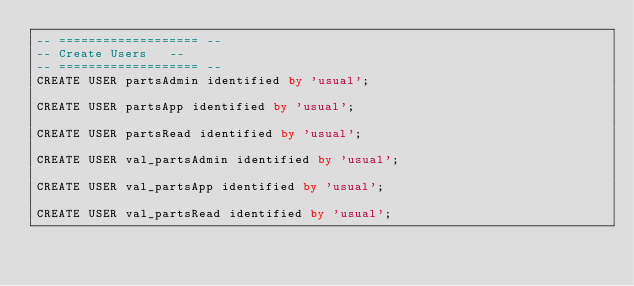Convert code to text. <code><loc_0><loc_0><loc_500><loc_500><_SQL_>-- =================== --
-- Create Users   --
-- =================== --
CREATE USER partsAdmin identified by 'usual';

CREATE USER partsApp identified by 'usual';

CREATE USER partsRead identified by 'usual';

CREATE USER val_partsAdmin identified by 'usual';

CREATE USER val_partsApp identified by 'usual';

CREATE USER val_partsRead identified by 'usual';
</code> 